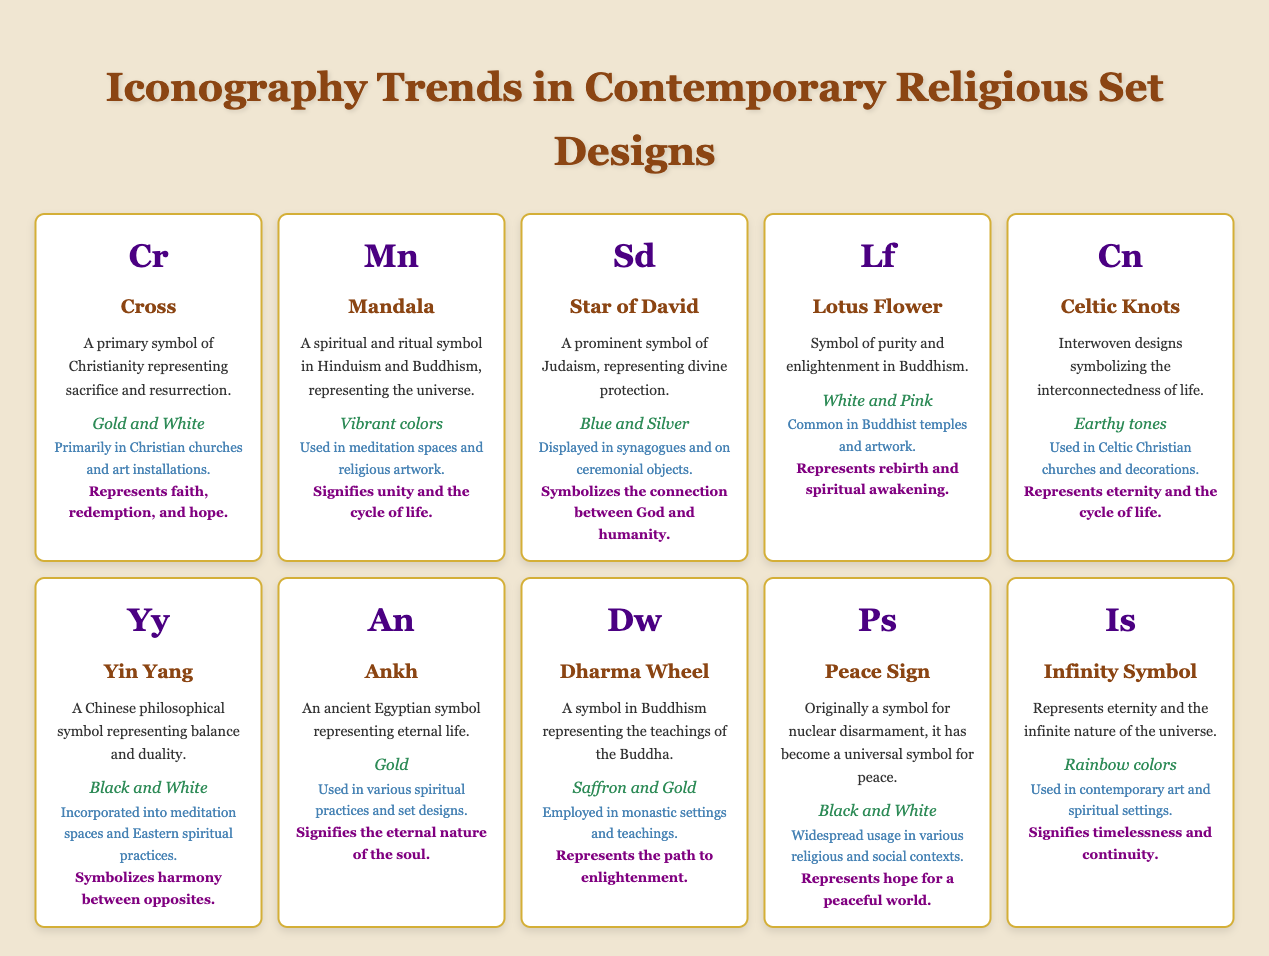What is the color theme of the Cross? The table lists the color theme for the Cross as "Gold and White" in the corresponding entry.
Answer: Gold and White Which symbol represents the teachings of the Buddha? The Dharma Wheel is identified as the symbol representing the teachings of the Buddha in the table.
Answer: Dharma Wheel How many symbols have earthy tone color themes? There is one entry with earthy tones listed in the table, which is the Celtic Knots.
Answer: 1 Is the Lotus Flower primarily associated with Buddhism? Yes, the table indicates that the Lotus Flower is a symbol of purity and enlightenment specifically in Buddhism.
Answer: Yes Which symbols are used in meditation spaces? Both the Mandala and Yin Yang are mentioned in the table as symbols used in meditation spaces.
Answer: Mandala, Yin Yang What symbol has the highest representation of colors? The Infinity Symbol has a rainbow color theme, which is the most diverse expression of color in the table.
Answer: Infinity Symbol How do the cultural significances of the Cross and Ankh compare? The Cross signifies faith, redemption, and hope, while the Ankh signifies the eternal nature of the soul; thus, they represent distinct spiritual concepts.
Answer: Different significances Count the number of symbols currently displayed in synagogues. The table indicates that only the Star of David is currently displayed in synagogues, making it a single instance for this category.
Answer: 1 Is the Peace Sign associated with a specific religious tradition? No, the Peace Sign is portrayed as a universal symbol, thus not confined to a specific religious tradition according to the table.
Answer: No Which two symbols are associated with notions of eternity? The Ankh and the Infinity Symbol are both associated with notions of eternity as per their respective descriptions in the table.
Answer: Ankh, Infinity Symbol 